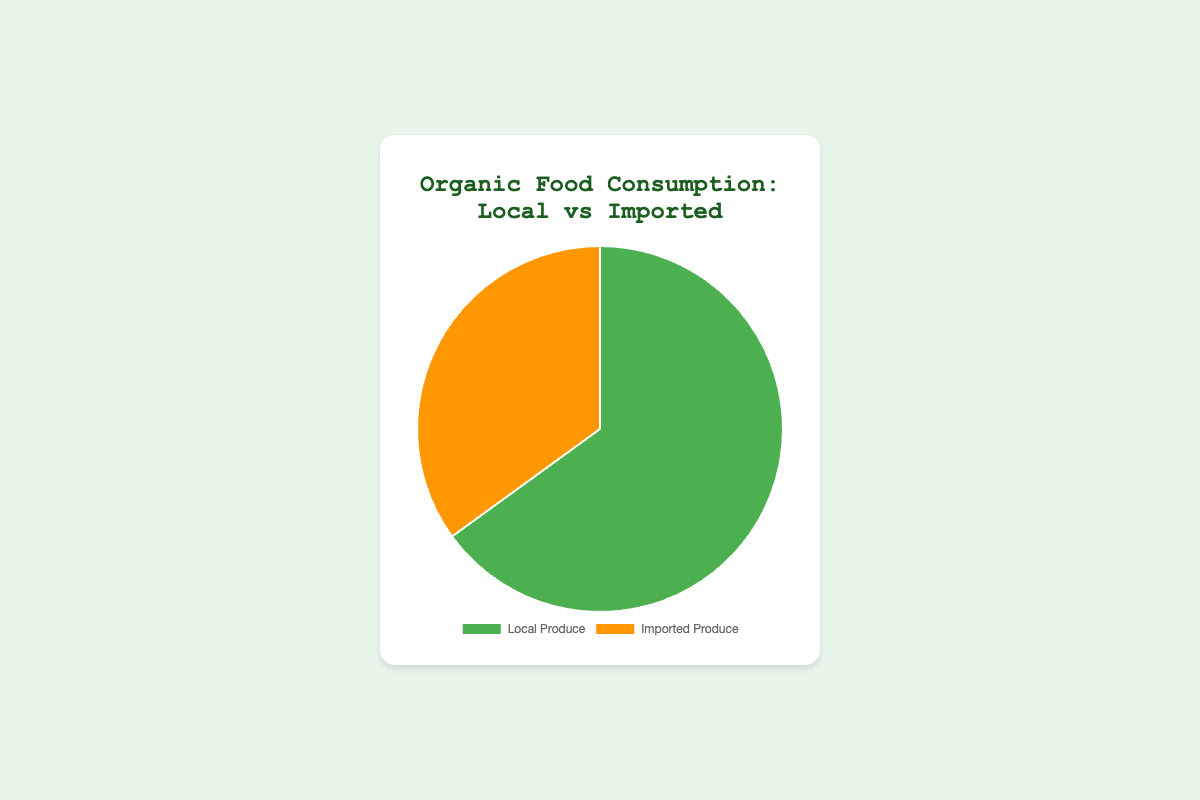What's the percentage of local produce? The pie chart shows two categories, Local Produce and Imported Produce, with respective percentages of 65% and 35%.
Answer: 65% What is the percentage difference between Local Produce and Imported Produce? The percentage for Local Produce is 65%, while for Imported Produce, it is 35%. The difference is 65% - 35% = 30%.
Answer: 30% Which category has the smaller percentage? The pie chart shows Local Produce at 65% and Imported Produce at 35%. Therefore, Imported Produce has the smaller percentage.
Answer: Imported Produce How much more local produce is consumed compared to imported produce, percentage-wise? Local Produce is 65% and Imported Produce is 35%. Subtract 35% from 65% to find the difference: 65% - 35% = 30%.
Answer: 30% What is the total percentage represented in the pie chart? The pie chart shows two segments, Local Produce and Imported Produce, summing up their percentages: 65% + 35% = 100%.
Answer: 100% Which visual attribute differentiates Local Produce from Imported Produce on the chart? The pie chart uses different colors to represent each category: Local Produce is shown in green, and Imported Produce in orange.
Answer: Color Are local or imported organic foods represented by a larger segment on the pie chart? The segment representing Local Produce is larger with 65%, compared to the Imported Produce segment at 35%.
Answer: Local Produce What logical relationship exists between the percentages of Local Produce and Imported Produce? The percentage of Local Produce is roughly twice as much as the percentage of Imported Produce. (65% is about twice 35%.)
Answer: Local Produce is roughly twice Considering that Local Produce has three entities (Farmers' Market, CSA, Local Farms), what's the average contribution per entity? The contributions are 20%, 25%, and 20%. Summing these values gives 65%. Dividing by 3 entities: (20 + 25 + 20) / 3 = 21.67%.
Answer: 21.67% How does the contribution of Online Retailers compare to Farmers' Market in percentage terms? Online Retailers contribute 10% while Farmers' Market contributes 20%. The difference can be computed as 20% - 10% = 10%, meaning Farmers' Market contributes 10% more.
Answer: Farmers' Market contributes 10% more 